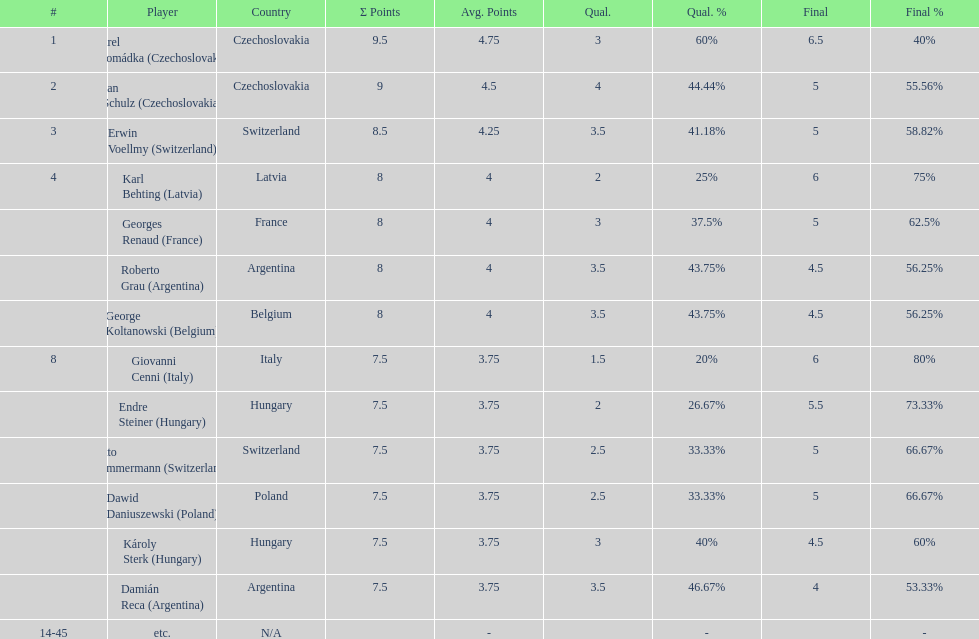How many countries had more than one player in the consolation cup? 4. Parse the table in full. {'header': ['#', 'Player', 'Country', 'Σ Points', 'Avg. Points', 'Qual.', 'Qual. %', 'Final', 'Final %'], 'rows': [['1', 'Karel Hromádka\xa0(Czechoslovakia)', 'Czechoslovakia', '9.5', '4.75', '3', '60%', '6.5', '40%'], ['2', 'Jan Schulz\xa0(Czechoslovakia)', 'Czechoslovakia', '9', '4.5', '4', '44.44%', '5', '55.56%'], ['3', 'Erwin Voellmy\xa0(Switzerland)', 'Switzerland', '8.5', '4.25', '3.5', '41.18%', '5', '58.82%'], ['4', 'Karl Behting\xa0(Latvia)', 'Latvia', '8', '4', '2', '25%', '6', '75%'], ['', 'Georges Renaud\xa0(France)', 'France', '8', '4', '3', '37.5%', '5', '62.5%'], ['', 'Roberto Grau\xa0(Argentina)', 'Argentina', '8', '4', '3.5', '43.75%', '4.5', '56.25%'], ['', 'George Koltanowski\xa0(Belgium)', 'Belgium', '8', '4', '3.5', '43.75%', '4.5', '56.25%'], ['8', 'Giovanni Cenni\xa0(Italy)', 'Italy', '7.5', '3.75', '1.5', '20%', '6', '80%'], ['', 'Endre Steiner\xa0(Hungary)', 'Hungary', '7.5', '3.75', '2', '26.67%', '5.5', '73.33%'], ['', 'Otto Zimmermann\xa0(Switzerland)', 'Switzerland', '7.5', '3.75', '2.5', '33.33%', '5', '66.67%'], ['', 'Dawid Daniuszewski\xa0(Poland)', 'Poland', '7.5', '3.75', '2.5', '33.33%', '5', '66.67%'], ['', 'Károly Sterk\xa0(Hungary)', 'Hungary', '7.5', '3.75', '3', '40%', '4.5', '60%'], ['', 'Damián Reca\xa0(Argentina)', 'Argentina', '7.5', '3.75', '3.5', '46.67%', '4', '53.33%'], ['14-45', 'etc.', 'N/A', '', '-', '', '-', '', '-']]} 